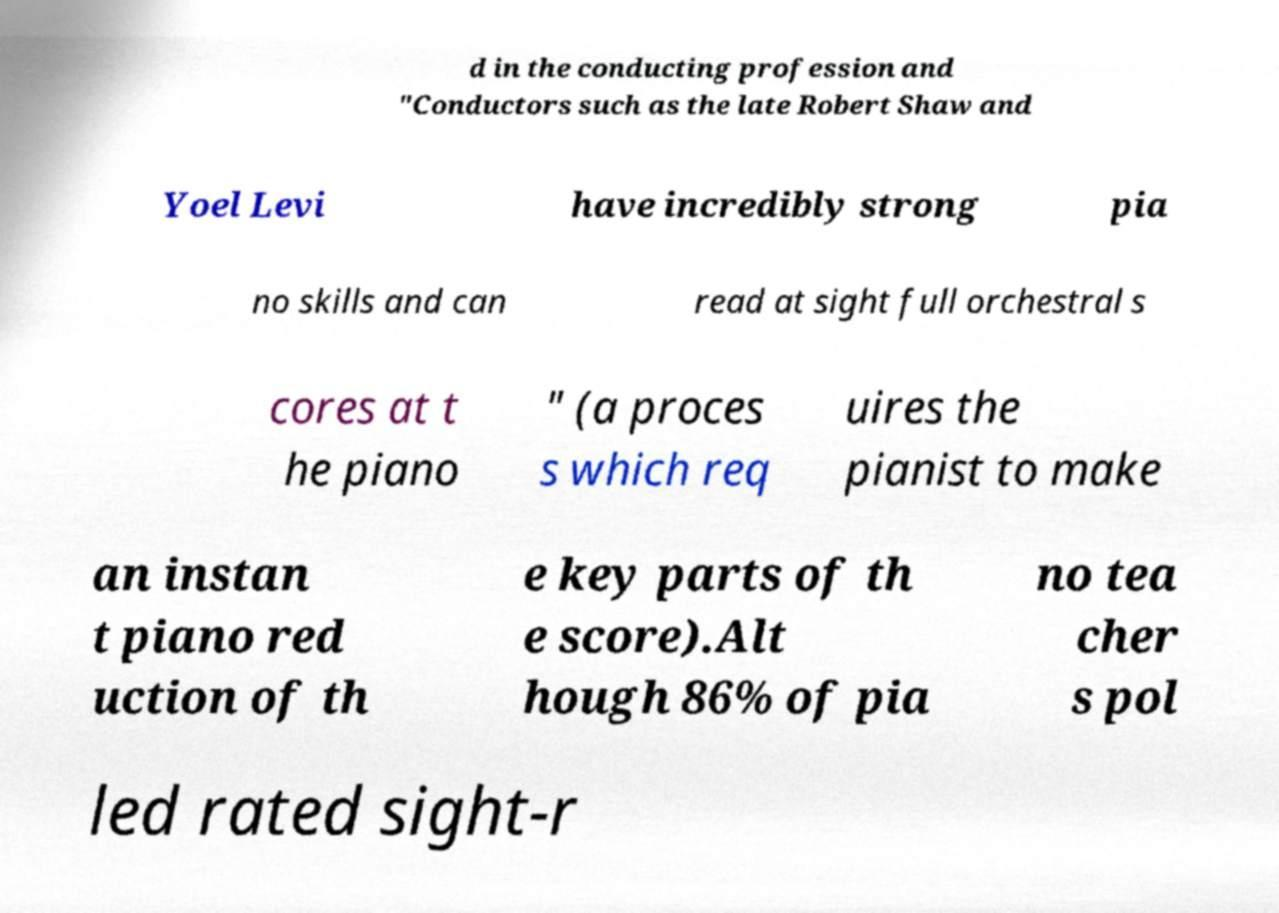Could you assist in decoding the text presented in this image and type it out clearly? d in the conducting profession and "Conductors such as the late Robert Shaw and Yoel Levi have incredibly strong pia no skills and can read at sight full orchestral s cores at t he piano " (a proces s which req uires the pianist to make an instan t piano red uction of th e key parts of th e score).Alt hough 86% of pia no tea cher s pol led rated sight-r 